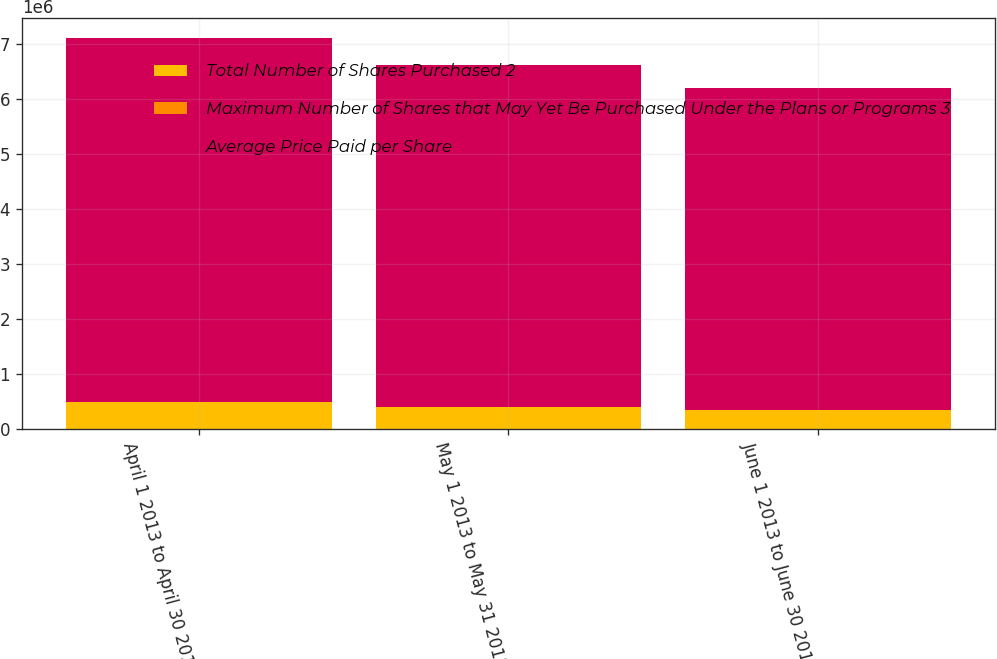Convert chart to OTSL. <chart><loc_0><loc_0><loc_500><loc_500><stacked_bar_chart><ecel><fcel>April 1 2013 to April 30 2013<fcel>May 1 2013 to May 31 2013<fcel>June 1 2013 to June 30 2013<nl><fcel>Total Number of Shares Purchased 2<fcel>494567<fcel>408900<fcel>355600<nl><fcel>Maximum Number of Shares that May Yet Be Purchased Under the Plans or Programs 3<fcel>52.88<fcel>54.45<fcel>55.95<nl><fcel>Average Price Paid per Share<fcel>6.61623e+06<fcel>6.20733e+06<fcel>5.85173e+06<nl></chart> 